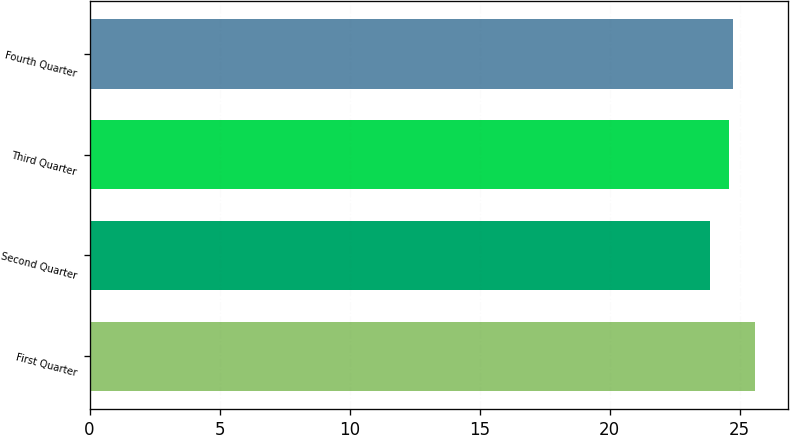<chart> <loc_0><loc_0><loc_500><loc_500><bar_chart><fcel>First Quarter<fcel>Second Quarter<fcel>Third Quarter<fcel>Fourth Quarter<nl><fcel>25.58<fcel>23.87<fcel>24.57<fcel>24.74<nl></chart> 